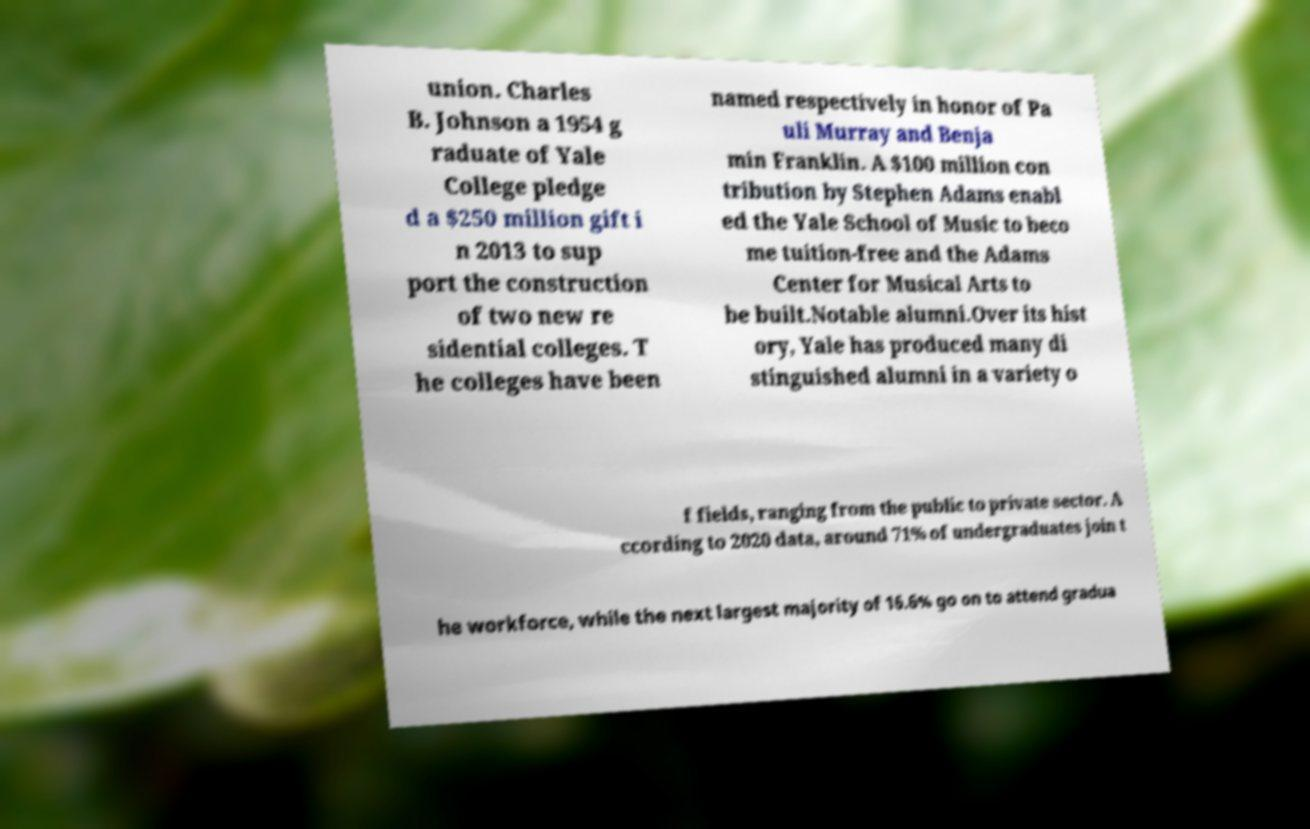Please identify and transcribe the text found in this image. union. Charles B. Johnson a 1954 g raduate of Yale College pledge d a $250 million gift i n 2013 to sup port the construction of two new re sidential colleges. T he colleges have been named respectively in honor of Pa uli Murray and Benja min Franklin. A $100 million con tribution by Stephen Adams enabl ed the Yale School of Music to beco me tuition-free and the Adams Center for Musical Arts to be built.Notable alumni.Over its hist ory, Yale has produced many di stinguished alumni in a variety o f fields, ranging from the public to private sector. A ccording to 2020 data, around 71% of undergraduates join t he workforce, while the next largest majority of 16.6% go on to attend gradua 